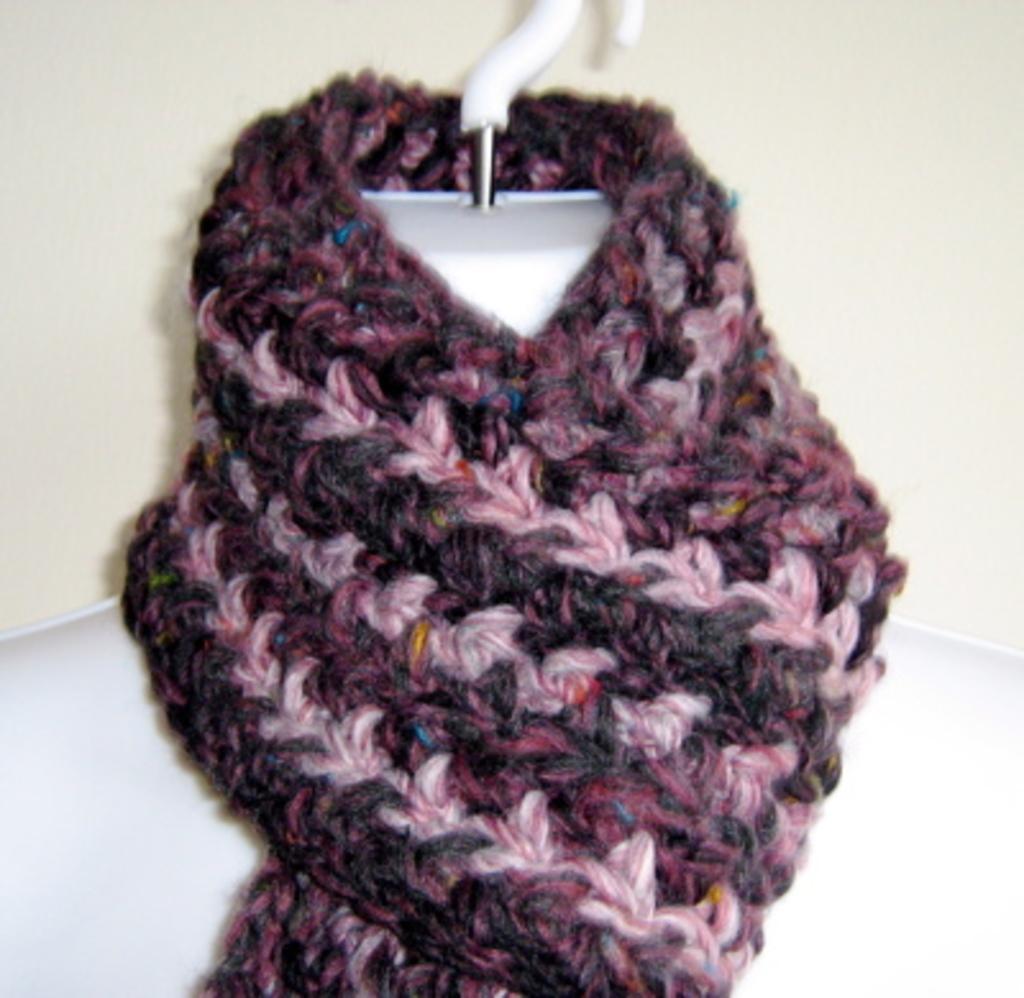Please provide a concise description of this image. In this picture we can see a cloth on mannequin neck. In the background of the image we can see wall. 